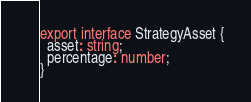Convert code to text. <code><loc_0><loc_0><loc_500><loc_500><_TypeScript_>export interface StrategyAsset {
  asset: string;
  percentage: number;
}
</code> 